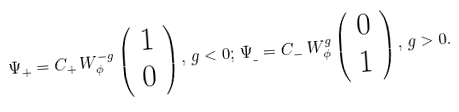<formula> <loc_0><loc_0><loc_500><loc_500>\Psi _ { + } = C _ { + } \, W _ { \phi } ^ { - g } \left ( \begin{array} { l } 1 \\ 0 \end{array} \right ) , \, g < 0 ; \, \Psi _ { \_ } = C _ { - } \, W _ { \phi } ^ { g } \left ( \begin{array} { l } 0 \\ 1 \end{array} \right ) , \, g > 0 .</formula> 